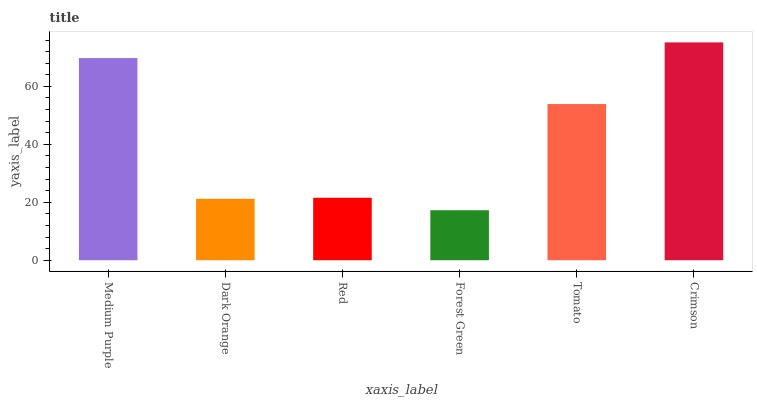Is Forest Green the minimum?
Answer yes or no. Yes. Is Crimson the maximum?
Answer yes or no. Yes. Is Dark Orange the minimum?
Answer yes or no. No. Is Dark Orange the maximum?
Answer yes or no. No. Is Medium Purple greater than Dark Orange?
Answer yes or no. Yes. Is Dark Orange less than Medium Purple?
Answer yes or no. Yes. Is Dark Orange greater than Medium Purple?
Answer yes or no. No. Is Medium Purple less than Dark Orange?
Answer yes or no. No. Is Tomato the high median?
Answer yes or no. Yes. Is Red the low median?
Answer yes or no. Yes. Is Red the high median?
Answer yes or no. No. Is Medium Purple the low median?
Answer yes or no. No. 